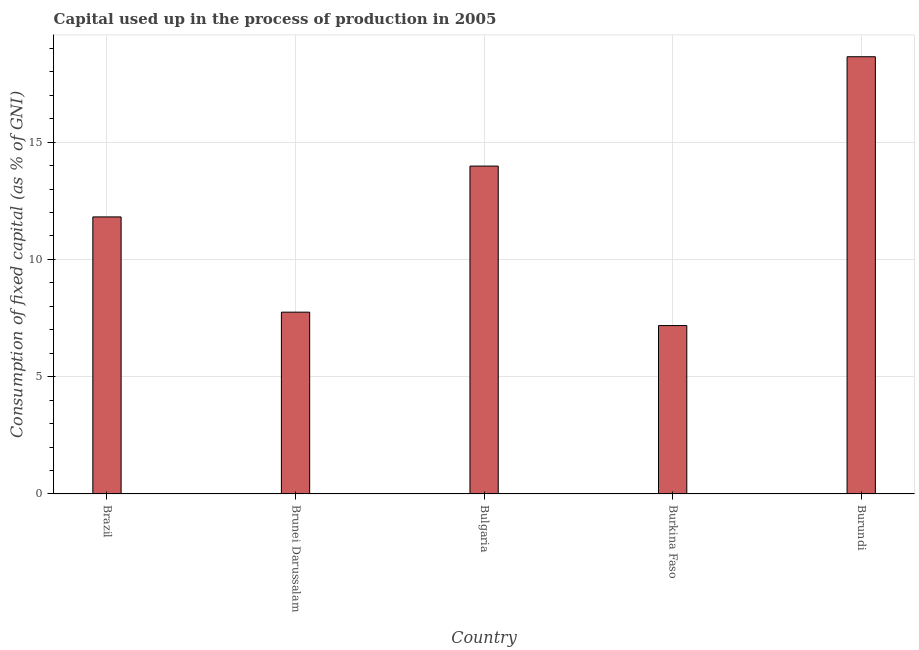Does the graph contain any zero values?
Keep it short and to the point. No. Does the graph contain grids?
Your response must be concise. Yes. What is the title of the graph?
Your response must be concise. Capital used up in the process of production in 2005. What is the label or title of the X-axis?
Keep it short and to the point. Country. What is the label or title of the Y-axis?
Offer a terse response. Consumption of fixed capital (as % of GNI). What is the consumption of fixed capital in Burundi?
Your response must be concise. 18.64. Across all countries, what is the maximum consumption of fixed capital?
Keep it short and to the point. 18.64. Across all countries, what is the minimum consumption of fixed capital?
Keep it short and to the point. 7.18. In which country was the consumption of fixed capital maximum?
Make the answer very short. Burundi. In which country was the consumption of fixed capital minimum?
Keep it short and to the point. Burkina Faso. What is the sum of the consumption of fixed capital?
Offer a very short reply. 59.37. What is the difference between the consumption of fixed capital in Brazil and Bulgaria?
Provide a short and direct response. -2.17. What is the average consumption of fixed capital per country?
Keep it short and to the point. 11.87. What is the median consumption of fixed capital?
Offer a very short reply. 11.81. Is the difference between the consumption of fixed capital in Brunei Darussalam and Bulgaria greater than the difference between any two countries?
Make the answer very short. No. What is the difference between the highest and the second highest consumption of fixed capital?
Ensure brevity in your answer.  4.66. Is the sum of the consumption of fixed capital in Brazil and Burundi greater than the maximum consumption of fixed capital across all countries?
Provide a succinct answer. Yes. What is the difference between the highest and the lowest consumption of fixed capital?
Ensure brevity in your answer.  11.46. How many bars are there?
Your response must be concise. 5. Are all the bars in the graph horizontal?
Keep it short and to the point. No. What is the difference between two consecutive major ticks on the Y-axis?
Make the answer very short. 5. What is the Consumption of fixed capital (as % of GNI) in Brazil?
Provide a short and direct response. 11.81. What is the Consumption of fixed capital (as % of GNI) in Brunei Darussalam?
Give a very brief answer. 7.75. What is the Consumption of fixed capital (as % of GNI) in Bulgaria?
Provide a short and direct response. 13.98. What is the Consumption of fixed capital (as % of GNI) of Burkina Faso?
Offer a terse response. 7.18. What is the Consumption of fixed capital (as % of GNI) in Burundi?
Offer a very short reply. 18.64. What is the difference between the Consumption of fixed capital (as % of GNI) in Brazil and Brunei Darussalam?
Give a very brief answer. 4.06. What is the difference between the Consumption of fixed capital (as % of GNI) in Brazil and Bulgaria?
Give a very brief answer. -2.17. What is the difference between the Consumption of fixed capital (as % of GNI) in Brazil and Burkina Faso?
Your response must be concise. 4.63. What is the difference between the Consumption of fixed capital (as % of GNI) in Brazil and Burundi?
Offer a very short reply. -6.83. What is the difference between the Consumption of fixed capital (as % of GNI) in Brunei Darussalam and Bulgaria?
Keep it short and to the point. -6.23. What is the difference between the Consumption of fixed capital (as % of GNI) in Brunei Darussalam and Burkina Faso?
Your answer should be compact. 0.57. What is the difference between the Consumption of fixed capital (as % of GNI) in Brunei Darussalam and Burundi?
Ensure brevity in your answer.  -10.89. What is the difference between the Consumption of fixed capital (as % of GNI) in Bulgaria and Burkina Faso?
Provide a short and direct response. 6.8. What is the difference between the Consumption of fixed capital (as % of GNI) in Bulgaria and Burundi?
Offer a terse response. -4.66. What is the difference between the Consumption of fixed capital (as % of GNI) in Burkina Faso and Burundi?
Give a very brief answer. -11.46. What is the ratio of the Consumption of fixed capital (as % of GNI) in Brazil to that in Brunei Darussalam?
Your answer should be compact. 1.52. What is the ratio of the Consumption of fixed capital (as % of GNI) in Brazil to that in Bulgaria?
Ensure brevity in your answer.  0.84. What is the ratio of the Consumption of fixed capital (as % of GNI) in Brazil to that in Burkina Faso?
Your response must be concise. 1.65. What is the ratio of the Consumption of fixed capital (as % of GNI) in Brazil to that in Burundi?
Your response must be concise. 0.63. What is the ratio of the Consumption of fixed capital (as % of GNI) in Brunei Darussalam to that in Bulgaria?
Provide a short and direct response. 0.55. What is the ratio of the Consumption of fixed capital (as % of GNI) in Brunei Darussalam to that in Burundi?
Provide a succinct answer. 0.42. What is the ratio of the Consumption of fixed capital (as % of GNI) in Bulgaria to that in Burkina Faso?
Provide a succinct answer. 1.95. What is the ratio of the Consumption of fixed capital (as % of GNI) in Burkina Faso to that in Burundi?
Your answer should be very brief. 0.39. 